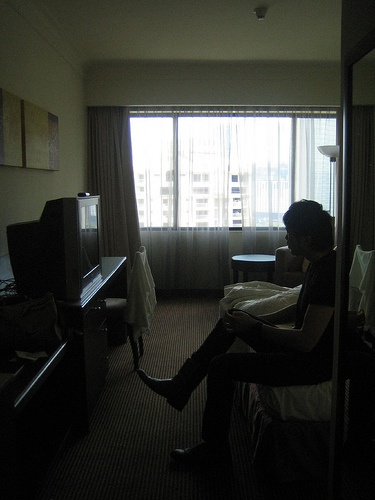Describe the objects in this image and their specific colors. I can see people in black, gray, and darkgray tones, couch in black and gray tones, tv in black, darkgray, and gray tones, bed in black and gray tones, and couch in black, gray, darkgray, and lightgray tones in this image. 